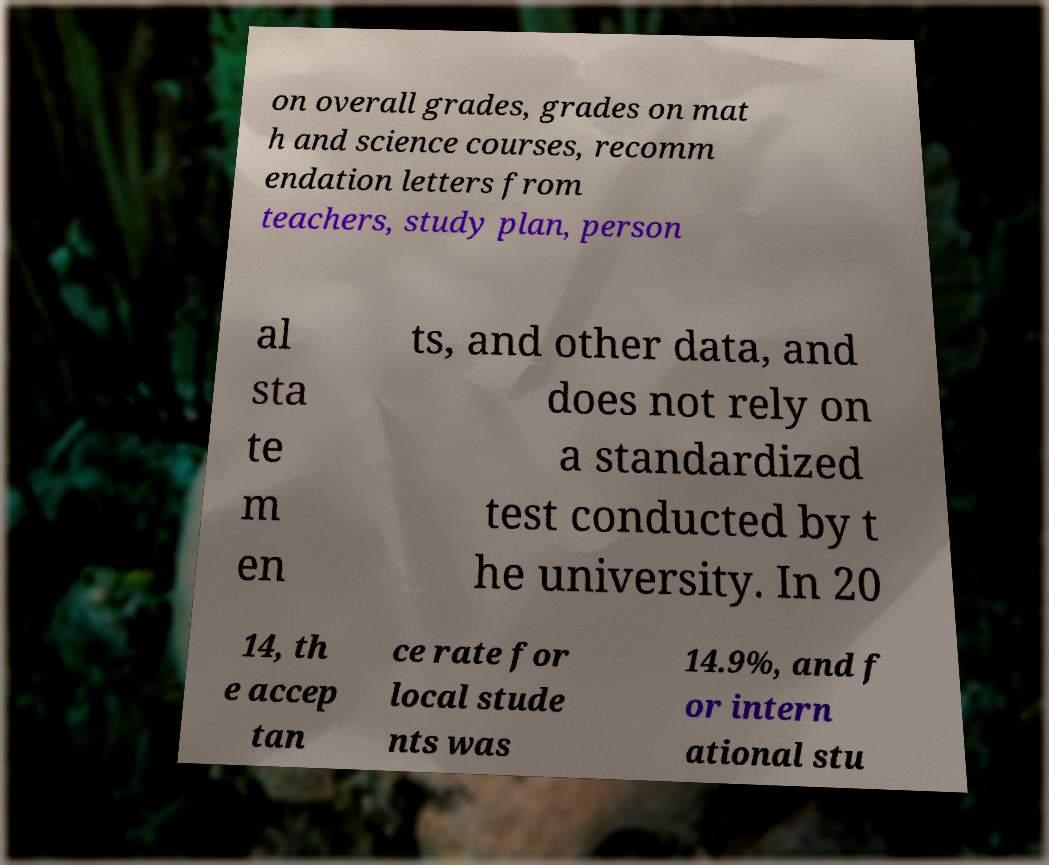Can you accurately transcribe the text from the provided image for me? on overall grades, grades on mat h and science courses, recomm endation letters from teachers, study plan, person al sta te m en ts, and other data, and does not rely on a standardized test conducted by t he university. In 20 14, th e accep tan ce rate for local stude nts was 14.9%, and f or intern ational stu 